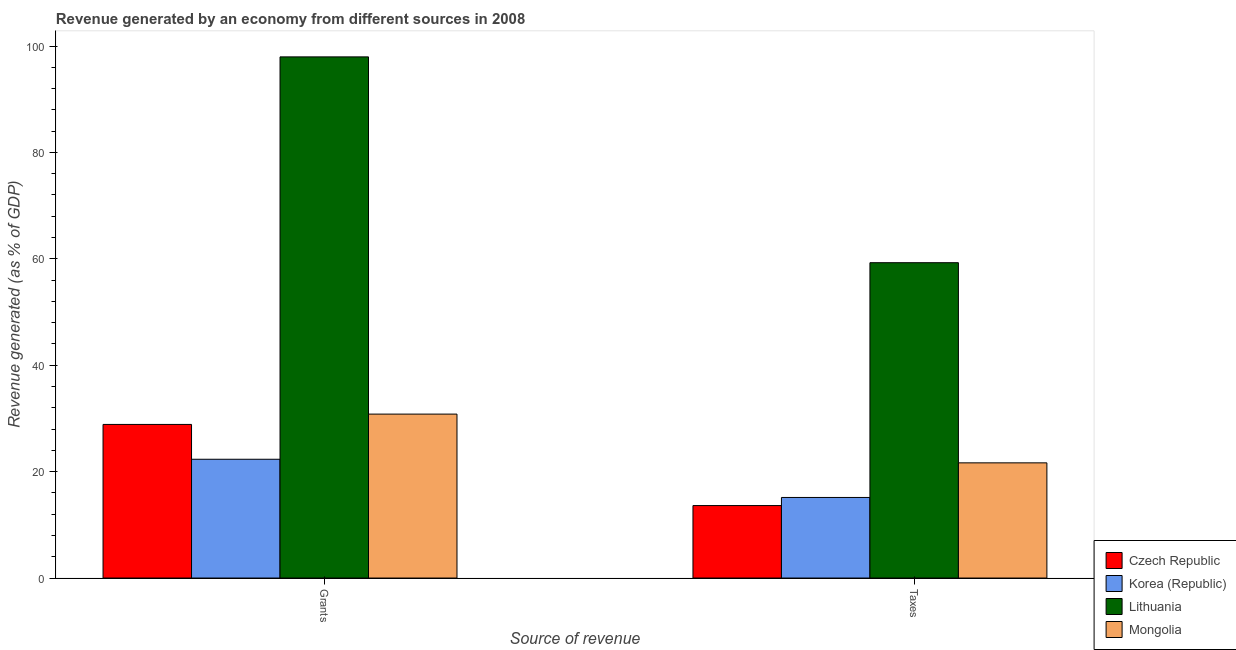How many different coloured bars are there?
Make the answer very short. 4. Are the number of bars per tick equal to the number of legend labels?
Your answer should be compact. Yes. Are the number of bars on each tick of the X-axis equal?
Ensure brevity in your answer.  Yes. How many bars are there on the 2nd tick from the left?
Provide a succinct answer. 4. What is the label of the 1st group of bars from the left?
Keep it short and to the point. Grants. What is the revenue generated by grants in Korea (Republic)?
Make the answer very short. 22.33. Across all countries, what is the maximum revenue generated by taxes?
Your answer should be very brief. 59.27. Across all countries, what is the minimum revenue generated by taxes?
Offer a very short reply. 13.62. In which country was the revenue generated by grants maximum?
Offer a very short reply. Lithuania. In which country was the revenue generated by grants minimum?
Your response must be concise. Korea (Republic). What is the total revenue generated by taxes in the graph?
Offer a terse response. 109.7. What is the difference between the revenue generated by grants in Mongolia and that in Lithuania?
Your response must be concise. -67.14. What is the difference between the revenue generated by grants in Lithuania and the revenue generated by taxes in Korea (Republic)?
Provide a short and direct response. 82.81. What is the average revenue generated by grants per country?
Offer a terse response. 44.99. What is the difference between the revenue generated by taxes and revenue generated by grants in Mongolia?
Your answer should be very brief. -9.16. What is the ratio of the revenue generated by taxes in Czech Republic to that in Mongolia?
Keep it short and to the point. 0.63. Is the revenue generated by grants in Mongolia less than that in Czech Republic?
Give a very brief answer. No. In how many countries, is the revenue generated by grants greater than the average revenue generated by grants taken over all countries?
Make the answer very short. 1. What does the 4th bar from the left in Taxes represents?
Make the answer very short. Mongolia. What does the 3rd bar from the right in Grants represents?
Make the answer very short. Korea (Republic). How many bars are there?
Provide a succinct answer. 8. Are all the bars in the graph horizontal?
Provide a short and direct response. No. How many countries are there in the graph?
Offer a very short reply. 4. What is the difference between two consecutive major ticks on the Y-axis?
Ensure brevity in your answer.  20. Does the graph contain grids?
Ensure brevity in your answer.  No. Where does the legend appear in the graph?
Keep it short and to the point. Bottom right. What is the title of the graph?
Provide a short and direct response. Revenue generated by an economy from different sources in 2008. What is the label or title of the X-axis?
Ensure brevity in your answer.  Source of revenue. What is the label or title of the Y-axis?
Your answer should be very brief. Revenue generated (as % of GDP). What is the Revenue generated (as % of GDP) in Czech Republic in Grants?
Offer a very short reply. 28.87. What is the Revenue generated (as % of GDP) in Korea (Republic) in Grants?
Give a very brief answer. 22.33. What is the Revenue generated (as % of GDP) of Lithuania in Grants?
Keep it short and to the point. 97.96. What is the Revenue generated (as % of GDP) of Mongolia in Grants?
Make the answer very short. 30.82. What is the Revenue generated (as % of GDP) of Czech Republic in Taxes?
Offer a very short reply. 13.62. What is the Revenue generated (as % of GDP) in Korea (Republic) in Taxes?
Ensure brevity in your answer.  15.15. What is the Revenue generated (as % of GDP) of Lithuania in Taxes?
Your answer should be compact. 59.27. What is the Revenue generated (as % of GDP) in Mongolia in Taxes?
Your answer should be very brief. 21.65. Across all Source of revenue, what is the maximum Revenue generated (as % of GDP) of Czech Republic?
Give a very brief answer. 28.87. Across all Source of revenue, what is the maximum Revenue generated (as % of GDP) in Korea (Republic)?
Provide a short and direct response. 22.33. Across all Source of revenue, what is the maximum Revenue generated (as % of GDP) in Lithuania?
Ensure brevity in your answer.  97.96. Across all Source of revenue, what is the maximum Revenue generated (as % of GDP) in Mongolia?
Keep it short and to the point. 30.82. Across all Source of revenue, what is the minimum Revenue generated (as % of GDP) in Czech Republic?
Offer a very short reply. 13.62. Across all Source of revenue, what is the minimum Revenue generated (as % of GDP) in Korea (Republic)?
Ensure brevity in your answer.  15.15. Across all Source of revenue, what is the minimum Revenue generated (as % of GDP) in Lithuania?
Provide a short and direct response. 59.27. Across all Source of revenue, what is the minimum Revenue generated (as % of GDP) of Mongolia?
Provide a short and direct response. 21.65. What is the total Revenue generated (as % of GDP) in Czech Republic in the graph?
Ensure brevity in your answer.  42.5. What is the total Revenue generated (as % of GDP) of Korea (Republic) in the graph?
Ensure brevity in your answer.  37.48. What is the total Revenue generated (as % of GDP) of Lithuania in the graph?
Offer a very short reply. 157.23. What is the total Revenue generated (as % of GDP) of Mongolia in the graph?
Keep it short and to the point. 52.47. What is the difference between the Revenue generated (as % of GDP) of Czech Republic in Grants and that in Taxes?
Your answer should be very brief. 15.25. What is the difference between the Revenue generated (as % of GDP) in Korea (Republic) in Grants and that in Taxes?
Give a very brief answer. 7.18. What is the difference between the Revenue generated (as % of GDP) in Lithuania in Grants and that in Taxes?
Your answer should be compact. 38.69. What is the difference between the Revenue generated (as % of GDP) in Mongolia in Grants and that in Taxes?
Provide a succinct answer. 9.16. What is the difference between the Revenue generated (as % of GDP) of Czech Republic in Grants and the Revenue generated (as % of GDP) of Korea (Republic) in Taxes?
Give a very brief answer. 13.73. What is the difference between the Revenue generated (as % of GDP) of Czech Republic in Grants and the Revenue generated (as % of GDP) of Lithuania in Taxes?
Your answer should be very brief. -30.4. What is the difference between the Revenue generated (as % of GDP) in Czech Republic in Grants and the Revenue generated (as % of GDP) in Mongolia in Taxes?
Provide a short and direct response. 7.22. What is the difference between the Revenue generated (as % of GDP) in Korea (Republic) in Grants and the Revenue generated (as % of GDP) in Lithuania in Taxes?
Your answer should be very brief. -36.95. What is the difference between the Revenue generated (as % of GDP) of Korea (Republic) in Grants and the Revenue generated (as % of GDP) of Mongolia in Taxes?
Give a very brief answer. 0.68. What is the difference between the Revenue generated (as % of GDP) of Lithuania in Grants and the Revenue generated (as % of GDP) of Mongolia in Taxes?
Make the answer very short. 76.31. What is the average Revenue generated (as % of GDP) of Czech Republic per Source of revenue?
Ensure brevity in your answer.  21.25. What is the average Revenue generated (as % of GDP) of Korea (Republic) per Source of revenue?
Give a very brief answer. 18.74. What is the average Revenue generated (as % of GDP) in Lithuania per Source of revenue?
Keep it short and to the point. 78.62. What is the average Revenue generated (as % of GDP) of Mongolia per Source of revenue?
Your answer should be compact. 26.23. What is the difference between the Revenue generated (as % of GDP) in Czech Republic and Revenue generated (as % of GDP) in Korea (Republic) in Grants?
Make the answer very short. 6.55. What is the difference between the Revenue generated (as % of GDP) in Czech Republic and Revenue generated (as % of GDP) in Lithuania in Grants?
Your answer should be compact. -69.09. What is the difference between the Revenue generated (as % of GDP) of Czech Republic and Revenue generated (as % of GDP) of Mongolia in Grants?
Offer a very short reply. -1.94. What is the difference between the Revenue generated (as % of GDP) of Korea (Republic) and Revenue generated (as % of GDP) of Lithuania in Grants?
Provide a succinct answer. -75.63. What is the difference between the Revenue generated (as % of GDP) of Korea (Republic) and Revenue generated (as % of GDP) of Mongolia in Grants?
Give a very brief answer. -8.49. What is the difference between the Revenue generated (as % of GDP) in Lithuania and Revenue generated (as % of GDP) in Mongolia in Grants?
Your response must be concise. 67.14. What is the difference between the Revenue generated (as % of GDP) in Czech Republic and Revenue generated (as % of GDP) in Korea (Republic) in Taxes?
Ensure brevity in your answer.  -1.53. What is the difference between the Revenue generated (as % of GDP) in Czech Republic and Revenue generated (as % of GDP) in Lithuania in Taxes?
Your answer should be very brief. -45.65. What is the difference between the Revenue generated (as % of GDP) of Czech Republic and Revenue generated (as % of GDP) of Mongolia in Taxes?
Provide a short and direct response. -8.03. What is the difference between the Revenue generated (as % of GDP) of Korea (Republic) and Revenue generated (as % of GDP) of Lithuania in Taxes?
Give a very brief answer. -44.13. What is the difference between the Revenue generated (as % of GDP) of Korea (Republic) and Revenue generated (as % of GDP) of Mongolia in Taxes?
Your answer should be very brief. -6.5. What is the difference between the Revenue generated (as % of GDP) in Lithuania and Revenue generated (as % of GDP) in Mongolia in Taxes?
Ensure brevity in your answer.  37.62. What is the ratio of the Revenue generated (as % of GDP) in Czech Republic in Grants to that in Taxes?
Provide a succinct answer. 2.12. What is the ratio of the Revenue generated (as % of GDP) in Korea (Republic) in Grants to that in Taxes?
Give a very brief answer. 1.47. What is the ratio of the Revenue generated (as % of GDP) of Lithuania in Grants to that in Taxes?
Your answer should be compact. 1.65. What is the ratio of the Revenue generated (as % of GDP) of Mongolia in Grants to that in Taxes?
Your answer should be compact. 1.42. What is the difference between the highest and the second highest Revenue generated (as % of GDP) of Czech Republic?
Your response must be concise. 15.25. What is the difference between the highest and the second highest Revenue generated (as % of GDP) of Korea (Republic)?
Make the answer very short. 7.18. What is the difference between the highest and the second highest Revenue generated (as % of GDP) in Lithuania?
Your answer should be compact. 38.69. What is the difference between the highest and the second highest Revenue generated (as % of GDP) in Mongolia?
Offer a very short reply. 9.16. What is the difference between the highest and the lowest Revenue generated (as % of GDP) of Czech Republic?
Your answer should be compact. 15.25. What is the difference between the highest and the lowest Revenue generated (as % of GDP) of Korea (Republic)?
Give a very brief answer. 7.18. What is the difference between the highest and the lowest Revenue generated (as % of GDP) in Lithuania?
Provide a short and direct response. 38.69. What is the difference between the highest and the lowest Revenue generated (as % of GDP) in Mongolia?
Your answer should be compact. 9.16. 